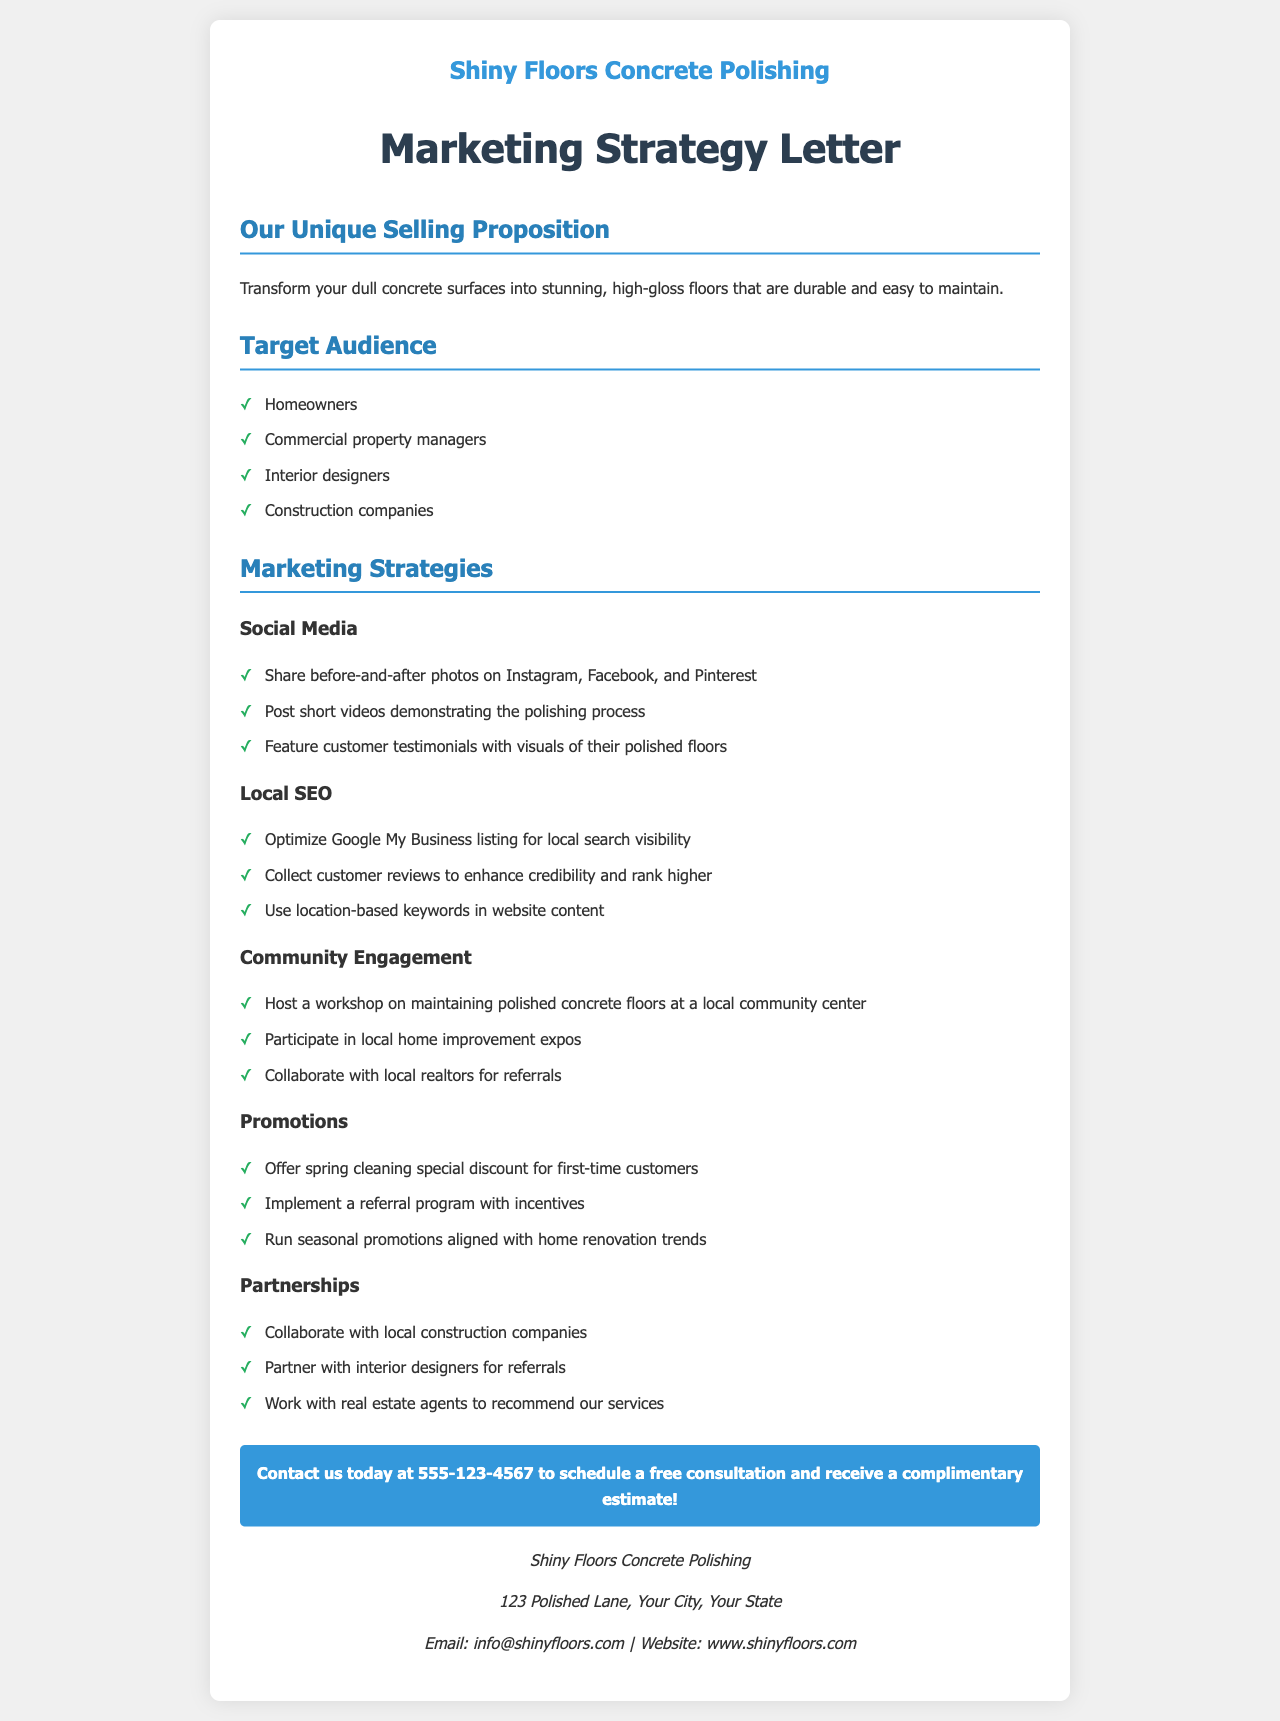What is the name of the business? The business name is mentioned at the beginning of the document.
Answer: Shiny Floors Concrete Polishing What is the primary service offered? The primary service is described in the Unique Selling Proposition section.
Answer: Concrete polishing Who is the target audience? The target audience is listed under a specific section in the document.
Answer: Homeowners, Commercial property managers, Interior designers, Construction companies What marketing strategy involves local search visibility? This marketing strategy is specifically mentioned in the document.
Answer: Local SEO What does the promotional spring cleaning offer target? The spring cleaning offer is mentioned under the Promotions section.
Answer: First-time customers Which social media platform is suggested for sharing before-and-after photos? The social media strategy mentions specific platforms for sharing visuals.
Answer: Instagram What is included in the contact information? The contact information section includes various ways to reach the business.
Answer: Phone number, email, and website What is the goal of community engagement strategies? The purpose of engaging with the community is implied through the activities listed.
Answer: Generate local interest and connections What collaborative partnership is suggested? The document suggests working with a specific type of professional for referrals.
Answer: Construction companies 